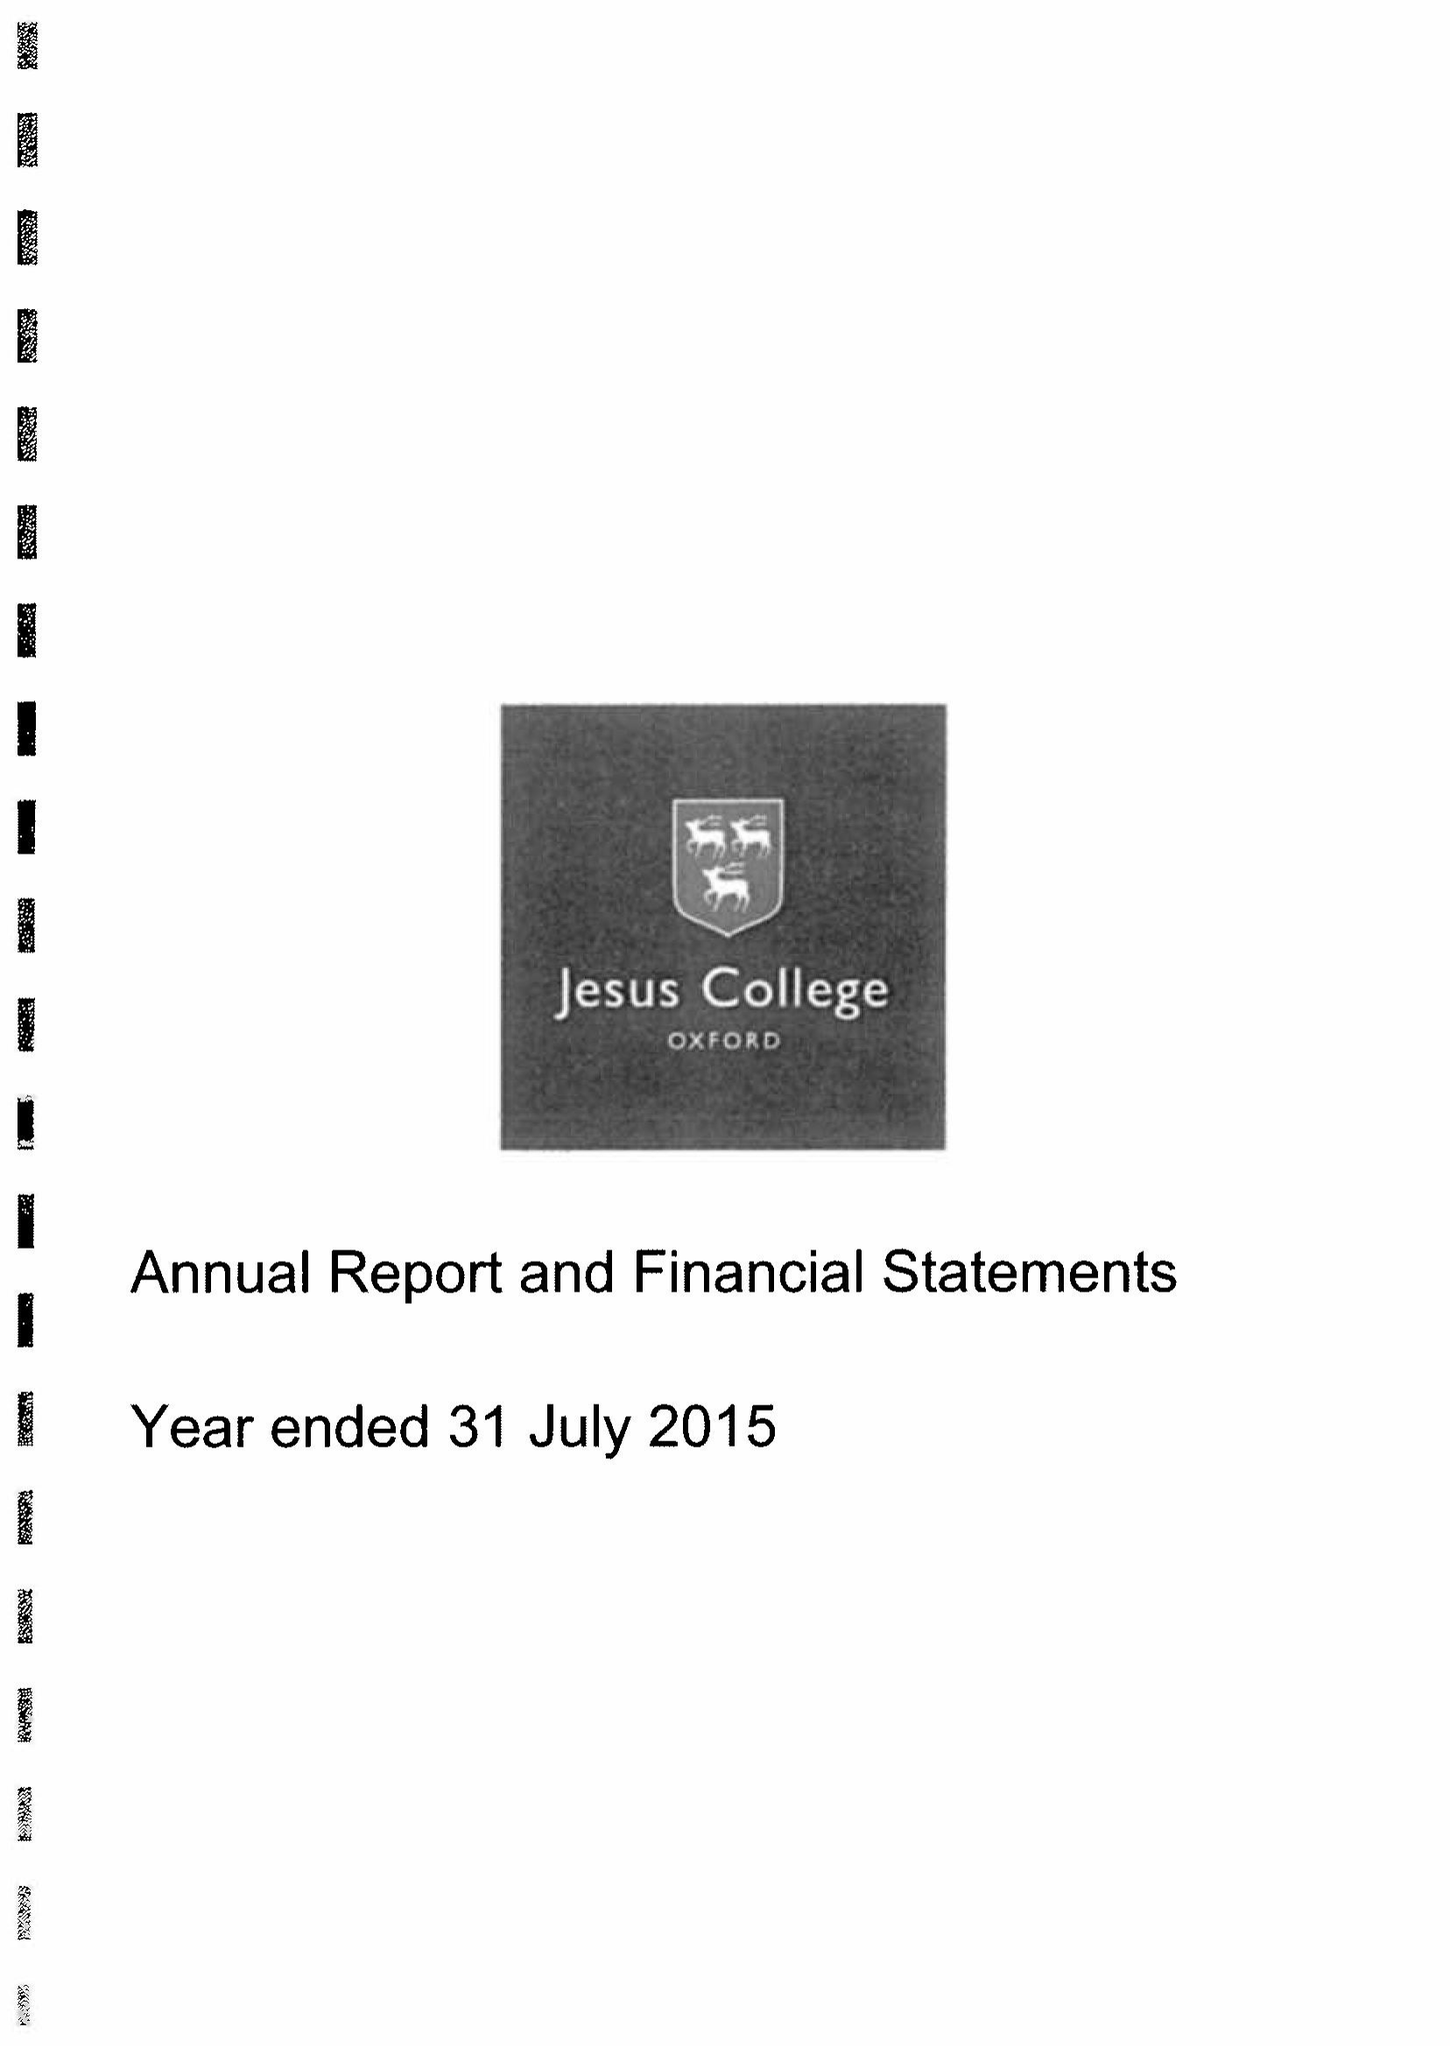What is the value for the charity_name?
Answer the question using a single word or phrase. Jesus College Within The University and City Of Oxford Of Queen Elizabeth's Foundation 